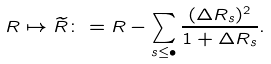Convert formula to latex. <formula><loc_0><loc_0><loc_500><loc_500>R \mapsto \widetilde { R } \colon = R - \sum _ { s \leq \bullet } \frac { ( \Delta R _ { s } ) ^ { 2 } } { 1 + \Delta R _ { s } } .</formula> 